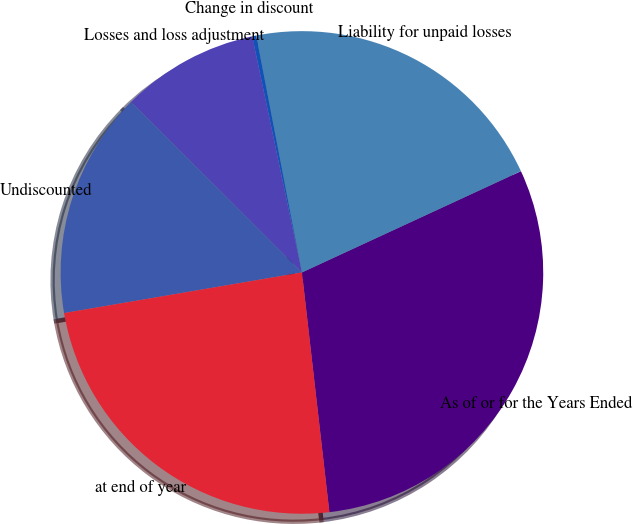Convert chart to OTSL. <chart><loc_0><loc_0><loc_500><loc_500><pie_chart><fcel>As of or for the Years Ended<fcel>Liability for unpaid losses<fcel>Change in discount<fcel>Losses and loss adjustment<fcel>Undiscounted<fcel>at end of year<nl><fcel>30.08%<fcel>21.14%<fcel>0.27%<fcel>9.21%<fcel>15.18%<fcel>24.12%<nl></chart> 